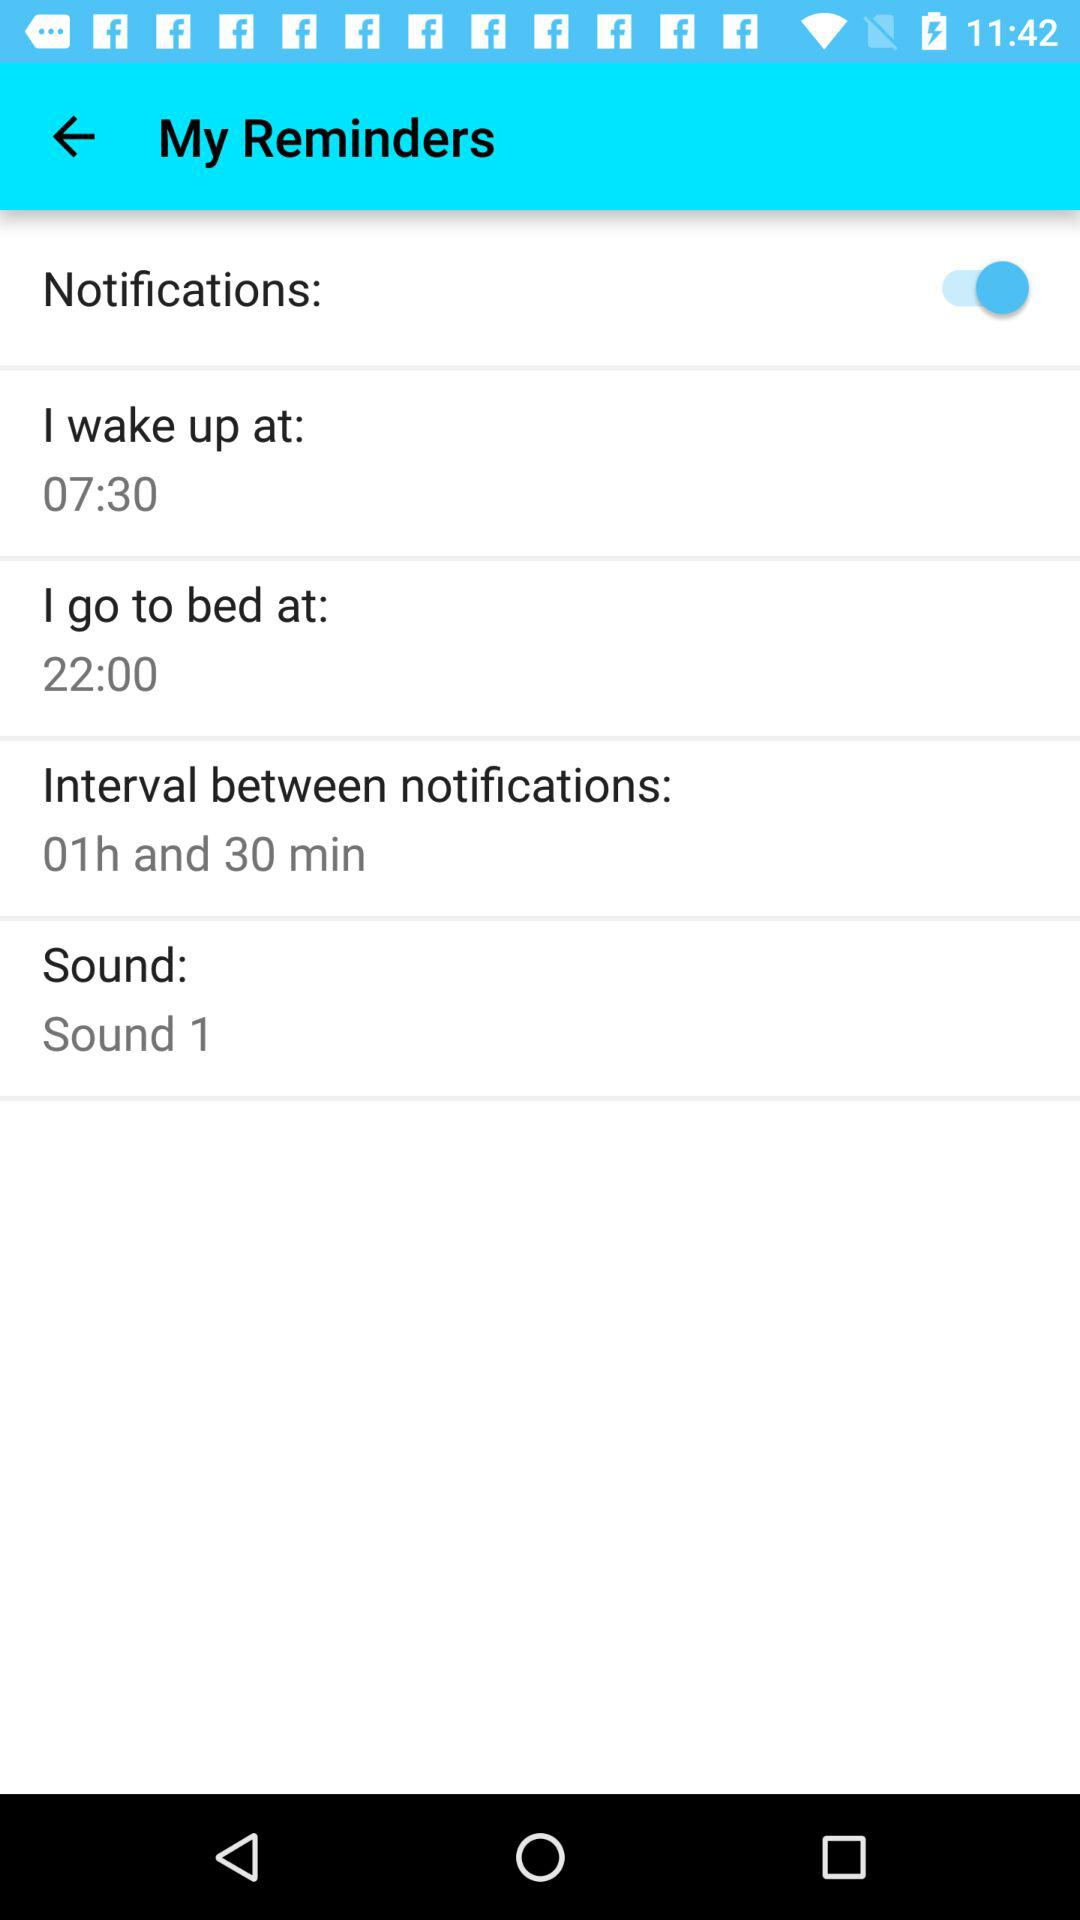What is the wakeup time? The wakeup time is 07:30. 